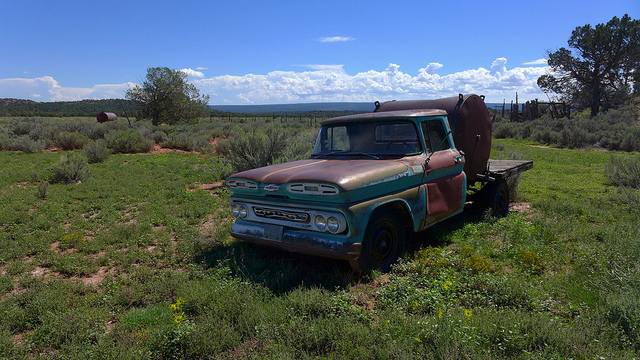What can you tell about the history of this truck based on its appearance? The truck appears to be a model from the late 1950s or early 1960s, which suggests it has been around for several decades. Its weathered paint and visible rust indicate it has been exposed to the elements for a long time, possibly sitting unused in this rural setting. Such vehicles often have a rich history, likely serving various utility purposes before being retired or abandoned. Is this type of truck considered valuable for collectors? Yes, trucks like this one can be highly valuable to collectors, especially those who appreciate vintage and classic vehicles. Its specific model and make, combined with the original parts and bodywork, even if weathered, increase its rarity and potential as a restoration project. The value can significantly rise if restored to its former glory. 